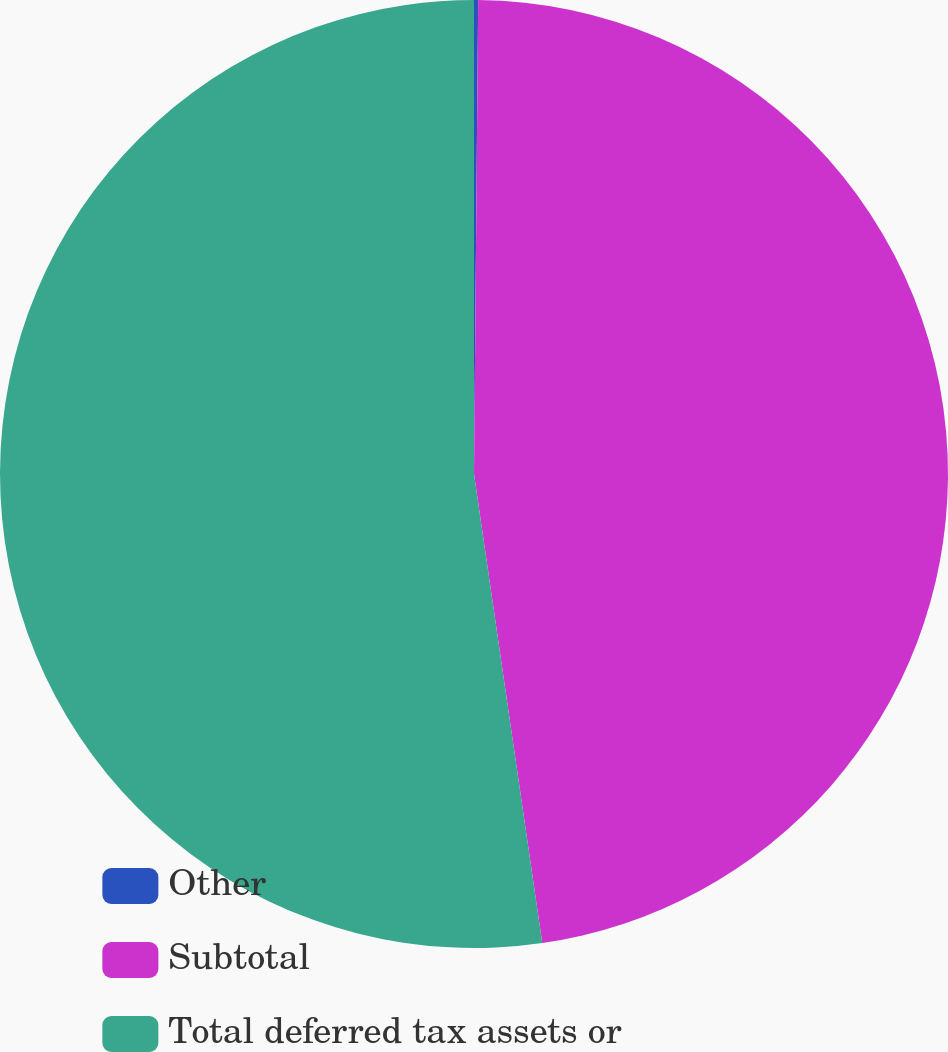Convert chart. <chart><loc_0><loc_0><loc_500><loc_500><pie_chart><fcel>Other<fcel>Subtotal<fcel>Total deferred tax assets or<nl><fcel>0.14%<fcel>47.56%<fcel>52.3%<nl></chart> 